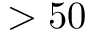<formula> <loc_0><loc_0><loc_500><loc_500>> 5 0</formula> 